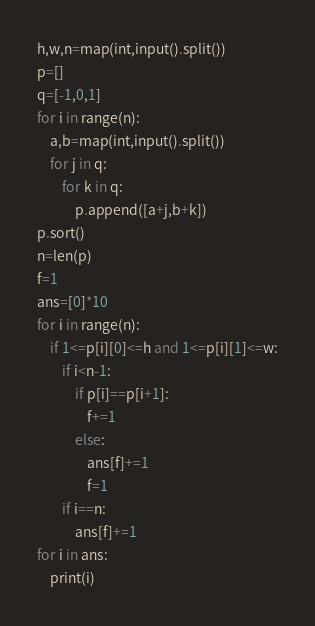Convert code to text. <code><loc_0><loc_0><loc_500><loc_500><_Python_>h,w,n=map(int,input().split())
p=[]
q=[-1,0,1]
for i in range(n):
    a,b=map(int,input().split())
    for j in q:
        for k in q:
            p.append([a+j,b+k])
p.sort()
n=len(p)
f=1
ans=[0]*10
for i in range(n):
    if 1<=p[i][0]<=h and 1<=p[i][1]<=w:
        if i<n-1:
            if p[i]==p[i+1]:
                f+=1
            else:
                ans[f]+=1
                f=1
        if i==n:
            ans[f]+=1
for i in ans:
    print(i)</code> 